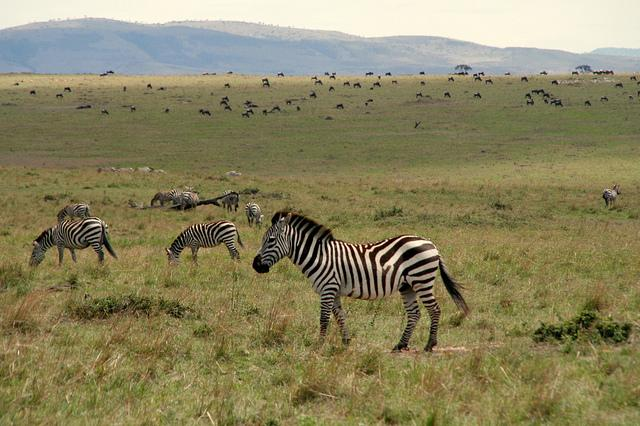What genus is this animal? equus 